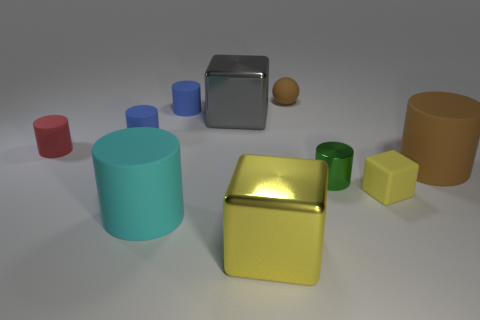There is a tiny red matte cylinder; are there any cylinders right of it?
Provide a short and direct response. Yes. What is the green thing made of?
Give a very brief answer. Metal. Is the color of the large shiny object in front of the big brown thing the same as the matte cube?
Your answer should be very brief. Yes. Is there anything else that has the same shape as the tiny brown rubber thing?
Your answer should be very brief. No. There is another big metallic thing that is the same shape as the gray object; what is its color?
Offer a very short reply. Yellow. What is the material of the big cylinder right of the tiny yellow cube?
Provide a short and direct response. Rubber. What color is the rubber sphere?
Make the answer very short. Brown. There is a yellow thing that is behind the yellow metal thing; does it have the same size as the brown rubber cylinder?
Give a very brief answer. No. The brown thing on the left side of the brown object in front of the block that is behind the green shiny cylinder is made of what material?
Provide a succinct answer. Rubber. Is the color of the large cylinder that is on the right side of the green metallic cylinder the same as the rubber sphere that is on the right side of the large yellow metal thing?
Offer a terse response. Yes. 